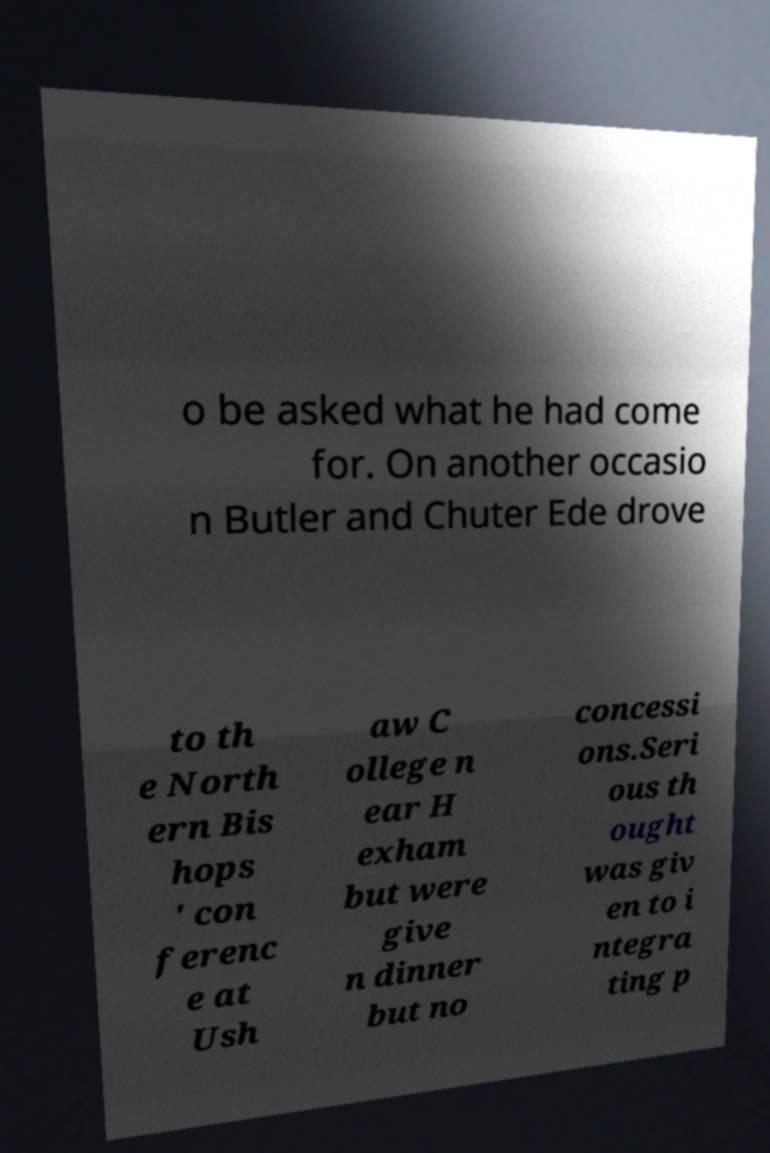Can you accurately transcribe the text from the provided image for me? o be asked what he had come for. On another occasio n Butler and Chuter Ede drove to th e North ern Bis hops ' con ferenc e at Ush aw C ollege n ear H exham but were give n dinner but no concessi ons.Seri ous th ought was giv en to i ntegra ting p 